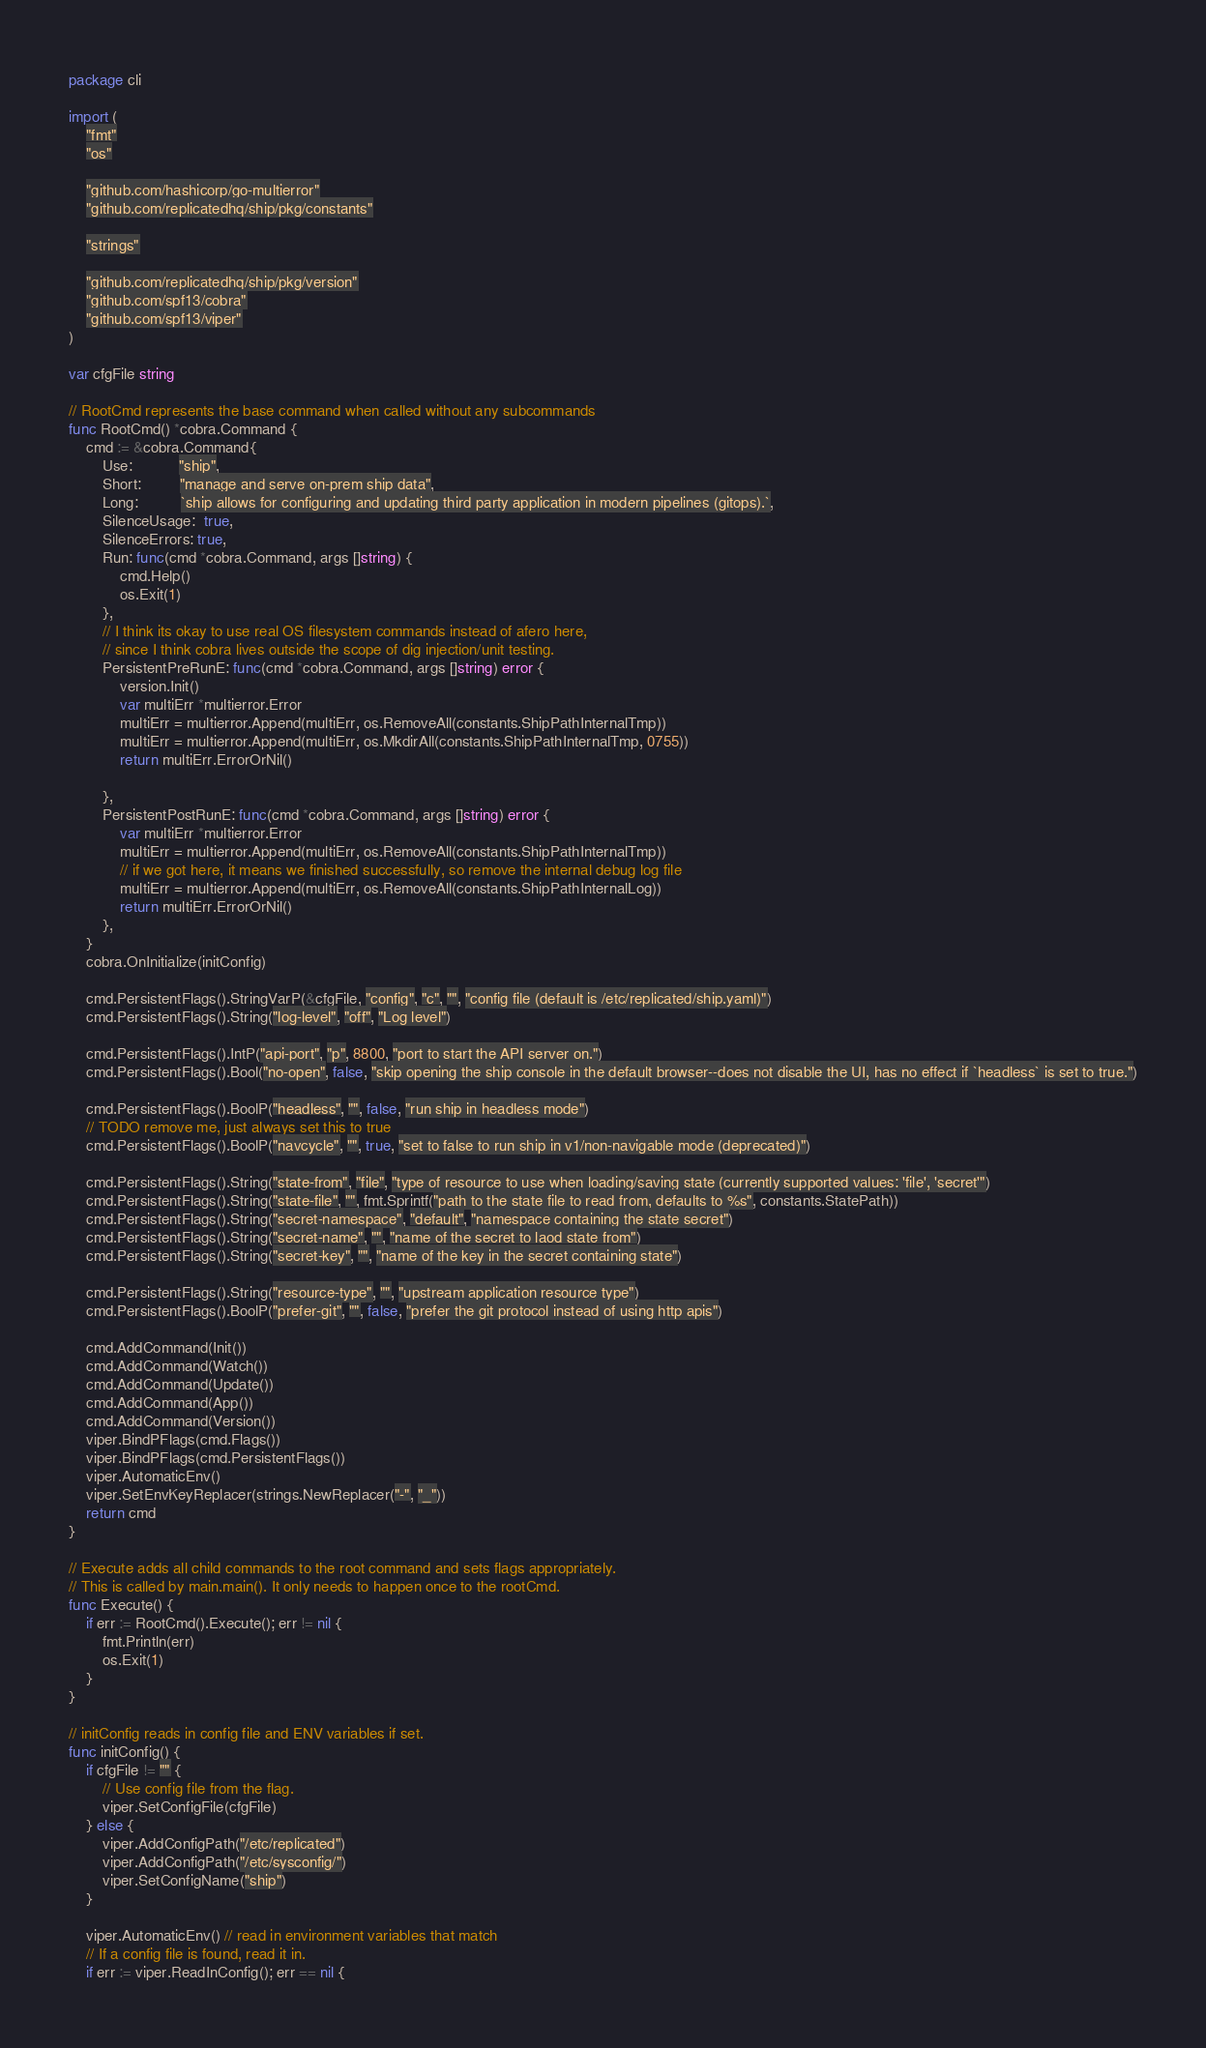<code> <loc_0><loc_0><loc_500><loc_500><_Go_>package cli

import (
	"fmt"
	"os"

	"github.com/hashicorp/go-multierror"
	"github.com/replicatedhq/ship/pkg/constants"

	"strings"

	"github.com/replicatedhq/ship/pkg/version"
	"github.com/spf13/cobra"
	"github.com/spf13/viper"
)

var cfgFile string

// RootCmd represents the base command when called without any subcommands
func RootCmd() *cobra.Command {
	cmd := &cobra.Command{
		Use:           "ship",
		Short:         "manage and serve on-prem ship data",
		Long:          `ship allows for configuring and updating third party application in modern pipelines (gitops).`,
		SilenceUsage:  true,
		SilenceErrors: true,
		Run: func(cmd *cobra.Command, args []string) {
			cmd.Help()
			os.Exit(1)
		},
		// I think its okay to use real OS filesystem commands instead of afero here,
		// since I think cobra lives outside the scope of dig injection/unit testing.
		PersistentPreRunE: func(cmd *cobra.Command, args []string) error {
			version.Init()
			var multiErr *multierror.Error
			multiErr = multierror.Append(multiErr, os.RemoveAll(constants.ShipPathInternalTmp))
			multiErr = multierror.Append(multiErr, os.MkdirAll(constants.ShipPathInternalTmp, 0755))
			return multiErr.ErrorOrNil()

		},
		PersistentPostRunE: func(cmd *cobra.Command, args []string) error {
			var multiErr *multierror.Error
			multiErr = multierror.Append(multiErr, os.RemoveAll(constants.ShipPathInternalTmp))
			// if we got here, it means we finished successfully, so remove the internal debug log file
			multiErr = multierror.Append(multiErr, os.RemoveAll(constants.ShipPathInternalLog))
			return multiErr.ErrorOrNil()
		},
	}
	cobra.OnInitialize(initConfig)

	cmd.PersistentFlags().StringVarP(&cfgFile, "config", "c", "", "config file (default is /etc/replicated/ship.yaml)")
	cmd.PersistentFlags().String("log-level", "off", "Log level")

	cmd.PersistentFlags().IntP("api-port", "p", 8800, "port to start the API server on.")
	cmd.PersistentFlags().Bool("no-open", false, "skip opening the ship console in the default browser--does not disable the UI, has no effect if `headless` is set to true.")

	cmd.PersistentFlags().BoolP("headless", "", false, "run ship in headless mode")
	// TODO remove me, just always set this to true
	cmd.PersistentFlags().BoolP("navcycle", "", true, "set to false to run ship in v1/non-navigable mode (deprecated)")

	cmd.PersistentFlags().String("state-from", "file", "type of resource to use when loading/saving state (currently supported values: 'file', 'secret'")
	cmd.PersistentFlags().String("state-file", "", fmt.Sprintf("path to the state file to read from, defaults to %s", constants.StatePath))
	cmd.PersistentFlags().String("secret-namespace", "default", "namespace containing the state secret")
	cmd.PersistentFlags().String("secret-name", "", "name of the secret to laod state from")
	cmd.PersistentFlags().String("secret-key", "", "name of the key in the secret containing state")

	cmd.PersistentFlags().String("resource-type", "", "upstream application resource type")
	cmd.PersistentFlags().BoolP("prefer-git", "", false, "prefer the git protocol instead of using http apis")

	cmd.AddCommand(Init())
	cmd.AddCommand(Watch())
	cmd.AddCommand(Update())
	cmd.AddCommand(App())
	cmd.AddCommand(Version())
	viper.BindPFlags(cmd.Flags())
	viper.BindPFlags(cmd.PersistentFlags())
	viper.AutomaticEnv()
	viper.SetEnvKeyReplacer(strings.NewReplacer("-", "_"))
	return cmd
}

// Execute adds all child commands to the root command and sets flags appropriately.
// This is called by main.main(). It only needs to happen once to the rootCmd.
func Execute() {
	if err := RootCmd().Execute(); err != nil {
		fmt.Println(err)
		os.Exit(1)
	}
}

// initConfig reads in config file and ENV variables if set.
func initConfig() {
	if cfgFile != "" {
		// Use config file from the flag.
		viper.SetConfigFile(cfgFile)
	} else {
		viper.AddConfigPath("/etc/replicated")
		viper.AddConfigPath("/etc/sysconfig/")
		viper.SetConfigName("ship")
	}

	viper.AutomaticEnv() // read in environment variables that match
	// If a config file is found, read it in.
	if err := viper.ReadInConfig(); err == nil {</code> 